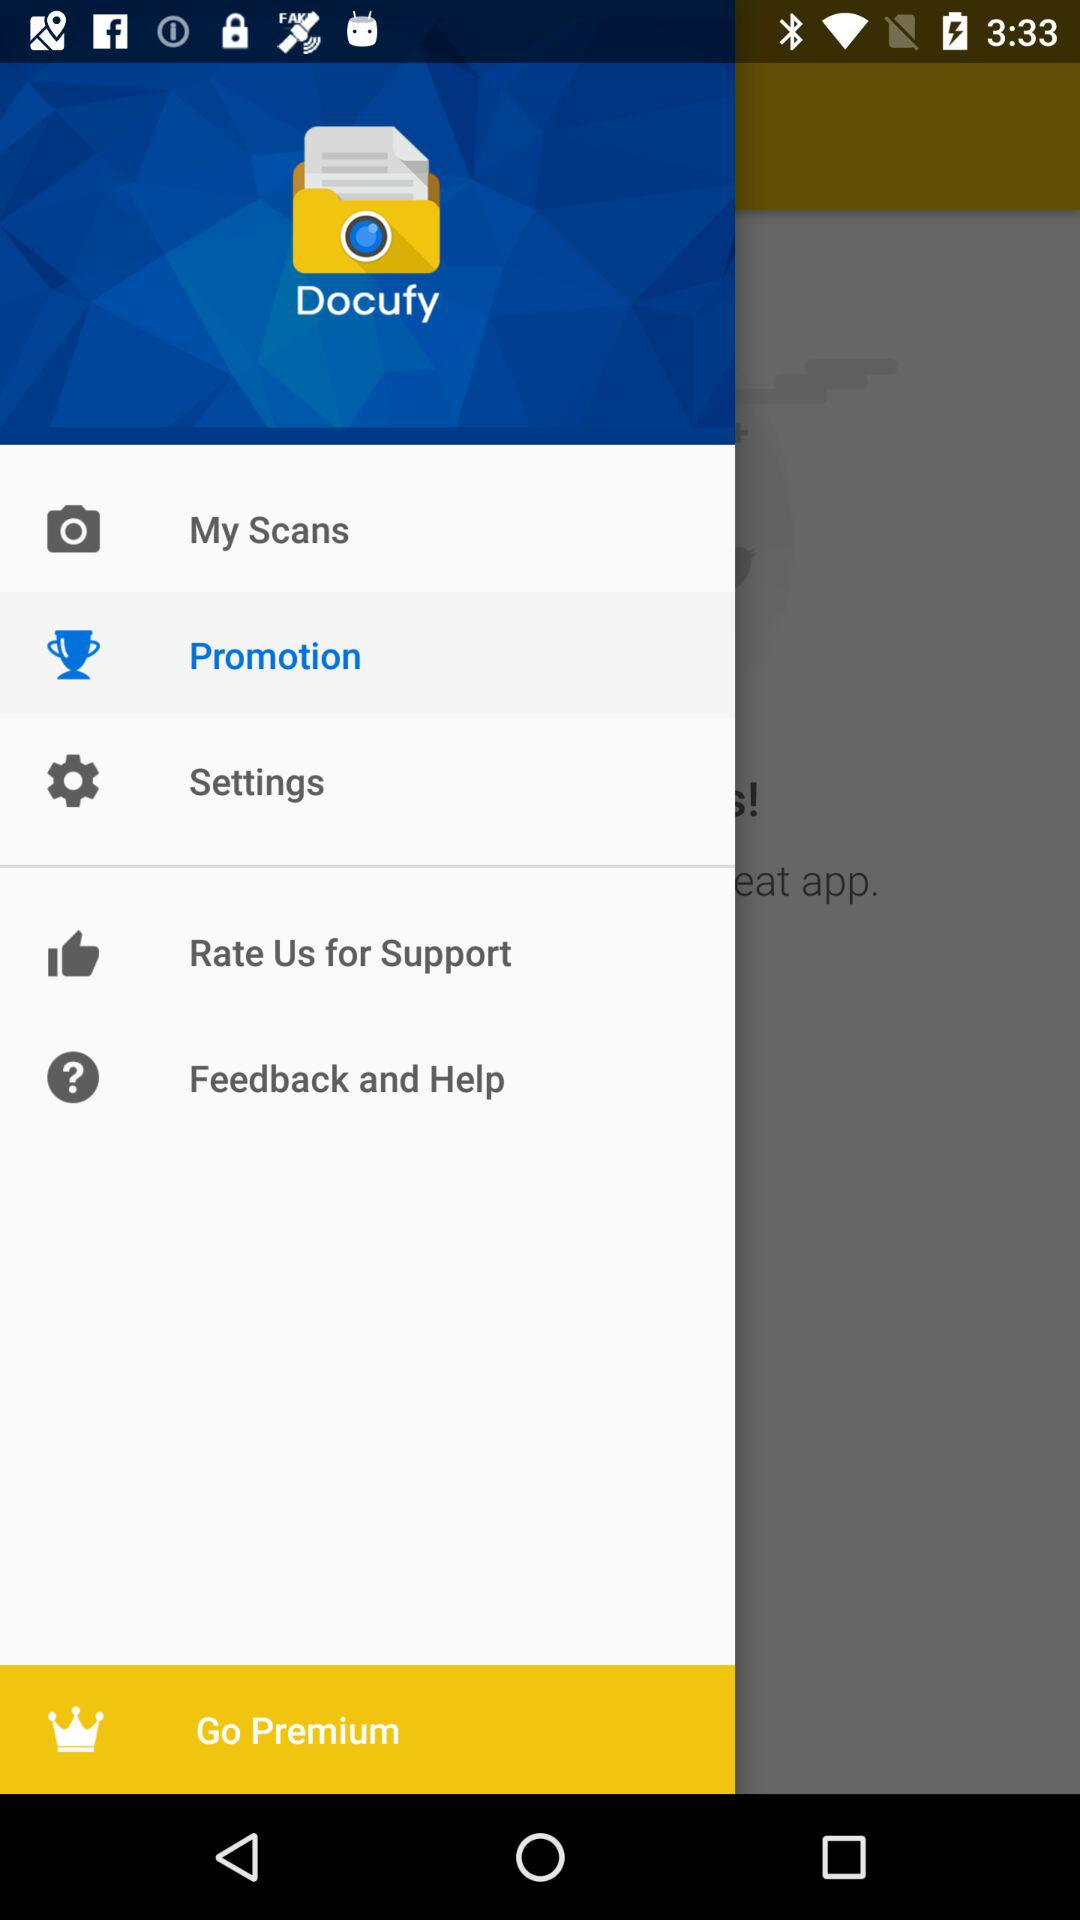What is the name of the application? The name of the application is "Docufy". 